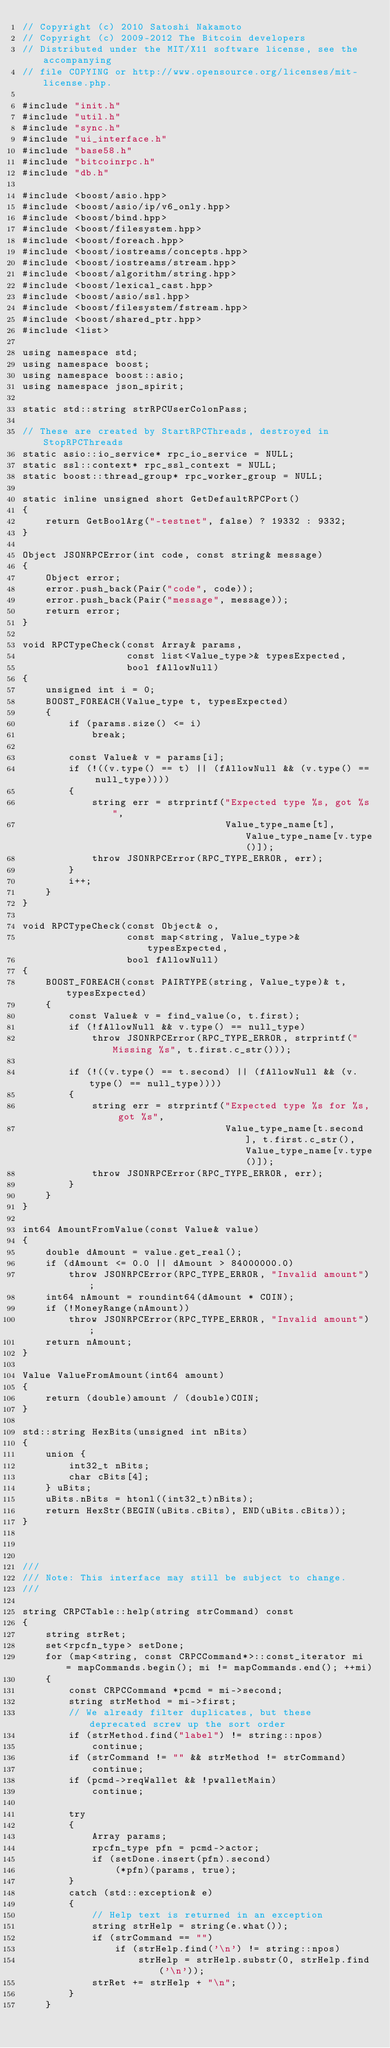<code> <loc_0><loc_0><loc_500><loc_500><_C++_>// Copyright (c) 2010 Satoshi Nakamoto
// Copyright (c) 2009-2012 The Bitcoin developers
// Distributed under the MIT/X11 software license, see the accompanying
// file COPYING or http://www.opensource.org/licenses/mit-license.php.

#include "init.h"
#include "util.h"
#include "sync.h"
#include "ui_interface.h"
#include "base58.h"
#include "bitcoinrpc.h"
#include "db.h"

#include <boost/asio.hpp>
#include <boost/asio/ip/v6_only.hpp>
#include <boost/bind.hpp>
#include <boost/filesystem.hpp>
#include <boost/foreach.hpp>
#include <boost/iostreams/concepts.hpp>
#include <boost/iostreams/stream.hpp>
#include <boost/algorithm/string.hpp>
#include <boost/lexical_cast.hpp>
#include <boost/asio/ssl.hpp>
#include <boost/filesystem/fstream.hpp>
#include <boost/shared_ptr.hpp>
#include <list>

using namespace std;
using namespace boost;
using namespace boost::asio;
using namespace json_spirit;

static std::string strRPCUserColonPass;

// These are created by StartRPCThreads, destroyed in StopRPCThreads
static asio::io_service* rpc_io_service = NULL;
static ssl::context* rpc_ssl_context = NULL;
static boost::thread_group* rpc_worker_group = NULL;

static inline unsigned short GetDefaultRPCPort()
{
    return GetBoolArg("-testnet", false) ? 19332 : 9332;
}

Object JSONRPCError(int code, const string& message)
{
    Object error;
    error.push_back(Pair("code", code));
    error.push_back(Pair("message", message));
    return error;
}

void RPCTypeCheck(const Array& params,
                  const list<Value_type>& typesExpected,
                  bool fAllowNull)
{
    unsigned int i = 0;
    BOOST_FOREACH(Value_type t, typesExpected)
    {
        if (params.size() <= i)
            break;

        const Value& v = params[i];
        if (!((v.type() == t) || (fAllowNull && (v.type() == null_type))))
        {
            string err = strprintf("Expected type %s, got %s",
                                   Value_type_name[t], Value_type_name[v.type()]);
            throw JSONRPCError(RPC_TYPE_ERROR, err);
        }
        i++;
    }
}

void RPCTypeCheck(const Object& o,
                  const map<string, Value_type>& typesExpected,
                  bool fAllowNull)
{
    BOOST_FOREACH(const PAIRTYPE(string, Value_type)& t, typesExpected)
    {
        const Value& v = find_value(o, t.first);
        if (!fAllowNull && v.type() == null_type)
            throw JSONRPCError(RPC_TYPE_ERROR, strprintf("Missing %s", t.first.c_str()));

        if (!((v.type() == t.second) || (fAllowNull && (v.type() == null_type))))
        {
            string err = strprintf("Expected type %s for %s, got %s",
                                   Value_type_name[t.second], t.first.c_str(), Value_type_name[v.type()]);
            throw JSONRPCError(RPC_TYPE_ERROR, err);
        }
    }
}

int64 AmountFromValue(const Value& value)
{
    double dAmount = value.get_real();
    if (dAmount <= 0.0 || dAmount > 84000000.0)
        throw JSONRPCError(RPC_TYPE_ERROR, "Invalid amount");
    int64 nAmount = roundint64(dAmount * COIN);
    if (!MoneyRange(nAmount))
        throw JSONRPCError(RPC_TYPE_ERROR, "Invalid amount");
    return nAmount;
}

Value ValueFromAmount(int64 amount)
{
    return (double)amount / (double)COIN;
}

std::string HexBits(unsigned int nBits)
{
    union {
        int32_t nBits;
        char cBits[4];
    } uBits;
    uBits.nBits = htonl((int32_t)nBits);
    return HexStr(BEGIN(uBits.cBits), END(uBits.cBits));
}



///
/// Note: This interface may still be subject to change.
///

string CRPCTable::help(string strCommand) const
{
    string strRet;
    set<rpcfn_type> setDone;
    for (map<string, const CRPCCommand*>::const_iterator mi = mapCommands.begin(); mi != mapCommands.end(); ++mi)
    {
        const CRPCCommand *pcmd = mi->second;
        string strMethod = mi->first;
        // We already filter duplicates, but these deprecated screw up the sort order
        if (strMethod.find("label") != string::npos)
            continue;
        if (strCommand != "" && strMethod != strCommand)
            continue;
        if (pcmd->reqWallet && !pwalletMain)
            continue;

        try
        {
            Array params;
            rpcfn_type pfn = pcmd->actor;
            if (setDone.insert(pfn).second)
                (*pfn)(params, true);
        }
        catch (std::exception& e)
        {
            // Help text is returned in an exception
            string strHelp = string(e.what());
            if (strCommand == "")
                if (strHelp.find('\n') != string::npos)
                    strHelp = strHelp.substr(0, strHelp.find('\n'));
            strRet += strHelp + "\n";
        }
    }</code> 